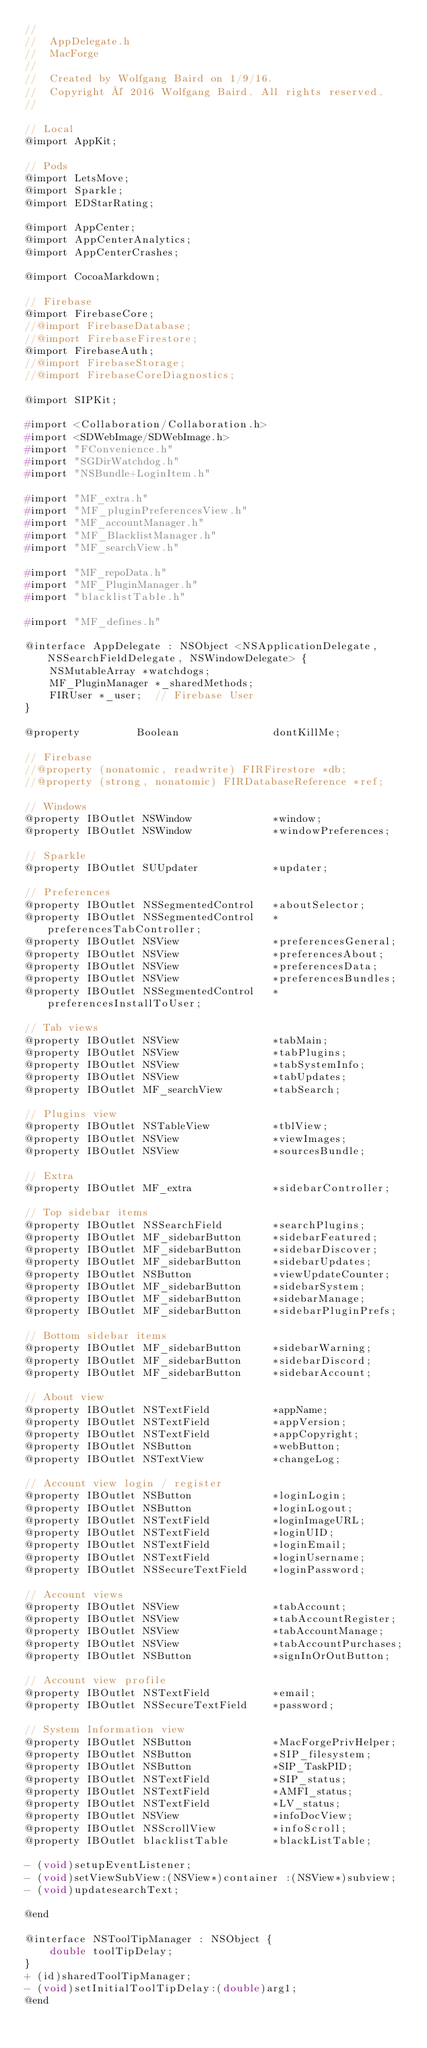Convert code to text. <code><loc_0><loc_0><loc_500><loc_500><_C_>//
//  AppDelegate.h
//  MacForge
//
//  Created by Wolfgang Baird on 1/9/16.
//  Copyright © 2016 Wolfgang Baird. All rights reserved.
//

// Local
@import AppKit;

// Pods
@import LetsMove;
@import Sparkle;
@import EDStarRating;

@import AppCenter;
@import AppCenterAnalytics;
@import AppCenterCrashes;

@import CocoaMarkdown;

// Firebase
@import FirebaseCore;
//@import FirebaseDatabase;
//@import FirebaseFirestore;
@import FirebaseAuth;
//@import FirebaseStorage;
//@import FirebaseCoreDiagnostics;

@import SIPKit;

#import <Collaboration/Collaboration.h>
#import <SDWebImage/SDWebImage.h>
#import "FConvenience.h"
#import "SGDirWatchdog.h"
#import "NSBundle+LoginItem.h"

#import "MF_extra.h"
#import "MF_pluginPreferencesView.h"
#import "MF_accountManager.h"
#import "MF_BlacklistManager.h"
#import "MF_searchView.h"

#import "MF_repoData.h"
#import "MF_PluginManager.h"
#import "blacklistTable.h"

#import "MF_defines.h"

@interface AppDelegate : NSObject <NSApplicationDelegate, NSSearchFieldDelegate, NSWindowDelegate> {
    NSMutableArray *watchdogs;
    MF_PluginManager *_sharedMethods;
    FIRUser *_user;  // Firebase User
}

@property         Boolean               dontKillMe;

// Firebase
//@property (nonatomic, readwrite) FIRFirestore *db;
//@property (strong, nonatomic) FIRDatabaseReference *ref;

// Windows
@property IBOutlet NSWindow             *window;
@property IBOutlet NSWindow             *windowPreferences;

// Sparkle
@property IBOutlet SUUpdater            *updater;

// Preferences
@property IBOutlet NSSegmentedControl   *aboutSelector;
@property IBOutlet NSSegmentedControl   *preferencesTabController;
@property IBOutlet NSView               *preferencesGeneral;
@property IBOutlet NSView               *preferencesAbout;
@property IBOutlet NSView               *preferencesData;
@property IBOutlet NSView               *preferencesBundles;
@property IBOutlet NSSegmentedControl   *preferencesInstallToUser;

// Tab views
@property IBOutlet NSView               *tabMain;
@property IBOutlet NSView               *tabPlugins;
@property IBOutlet NSView               *tabSystemInfo;
@property IBOutlet NSView               *tabUpdates;
@property IBOutlet MF_searchView        *tabSearch;

// Plugins view
@property IBOutlet NSTableView          *tblView;
@property IBOutlet NSView               *viewImages;
@property IBOutlet NSView               *sourcesBundle;

// Extra
@property IBOutlet MF_extra             *sidebarController;

// Top sidebar items
@property IBOutlet NSSearchField        *searchPlugins;
@property IBOutlet MF_sidebarButton     *sidebarFeatured;
@property IBOutlet MF_sidebarButton     *sidebarDiscover;
@property IBOutlet MF_sidebarButton     *sidebarUpdates;
@property IBOutlet NSButton             *viewUpdateCounter;
@property IBOutlet MF_sidebarButton     *sidebarSystem;
@property IBOutlet MF_sidebarButton     *sidebarManage;
@property IBOutlet MF_sidebarButton     *sidebarPluginPrefs;

// Bottom sidebar items
@property IBOutlet MF_sidebarButton     *sidebarWarning;
@property IBOutlet MF_sidebarButton     *sidebarDiscord;
@property IBOutlet MF_sidebarButton     *sidebarAccount;

// About view
@property IBOutlet NSTextField          *appName;
@property IBOutlet NSTextField          *appVersion;
@property IBOutlet NSTextField          *appCopyright;
@property IBOutlet NSButton             *webButton;
@property IBOutlet NSTextView           *changeLog;

// Account view login / register
@property IBOutlet NSButton             *loginLogin;
@property IBOutlet NSButton             *loginLogout;
@property IBOutlet NSTextField          *loginImageURL;
@property IBOutlet NSTextField          *loginUID;
@property IBOutlet NSTextField          *loginEmail;
@property IBOutlet NSTextField          *loginUsername;
@property IBOutlet NSSecureTextField    *loginPassword;

// Account views
@property IBOutlet NSView               *tabAccount;
@property IBOutlet NSView               *tabAccountRegister;
@property IBOutlet NSView               *tabAccountManage;
@property IBOutlet NSView               *tabAccountPurchases;
@property IBOutlet NSButton             *signInOrOutButton;

// Account view profile
@property IBOutlet NSTextField          *email;
@property IBOutlet NSSecureTextField    *password;

// System Information view
@property IBOutlet NSButton             *MacForgePrivHelper;
@property IBOutlet NSButton             *SIP_filesystem;
@property IBOutlet NSButton             *SIP_TaskPID;
@property IBOutlet NSTextField          *SIP_status;
@property IBOutlet NSTextField          *AMFI_status;
@property IBOutlet NSTextField          *LV_status;
@property IBOutlet NSView               *infoDocView;
@property IBOutlet NSScrollView         *infoScroll;
@property IBOutlet blacklistTable       *blackListTable;

- (void)setupEventListener;
- (void)setViewSubView:(NSView*)container :(NSView*)subview;
- (void)updatesearchText;

@end

@interface NSToolTipManager : NSObject {
    double toolTipDelay;
}
+ (id)sharedToolTipManager;
- (void)setInitialToolTipDelay:(double)arg1;
@end
</code> 